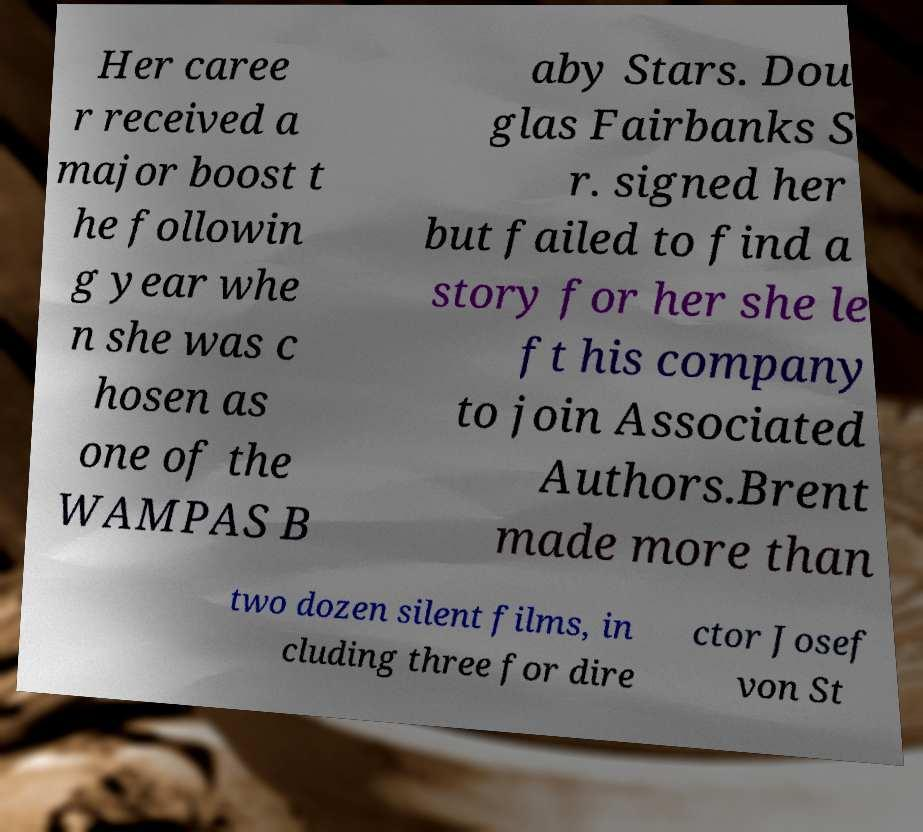For documentation purposes, I need the text within this image transcribed. Could you provide that? Her caree r received a major boost t he followin g year whe n she was c hosen as one of the WAMPAS B aby Stars. Dou glas Fairbanks S r. signed her but failed to find a story for her she le ft his company to join Associated Authors.Brent made more than two dozen silent films, in cluding three for dire ctor Josef von St 